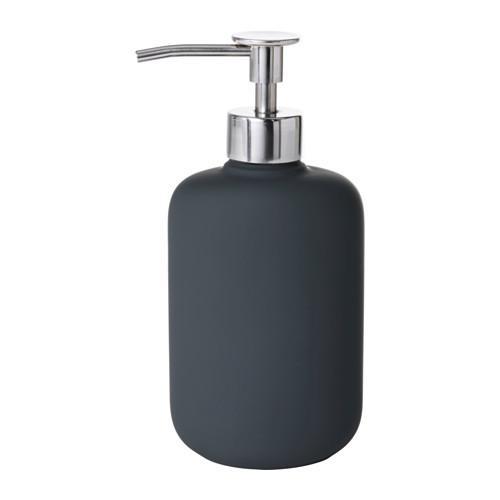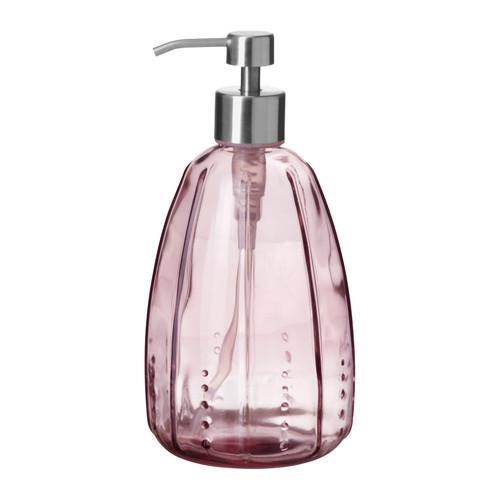The first image is the image on the left, the second image is the image on the right. Assess this claim about the two images: "Both dispensers have silver colored nozzles.". Correct or not? Answer yes or no. Yes. The first image is the image on the left, the second image is the image on the right. Considering the images on both sides, is "The left and right image contains the same number of sink soap dispensers with one sold bottle." valid? Answer yes or no. Yes. 